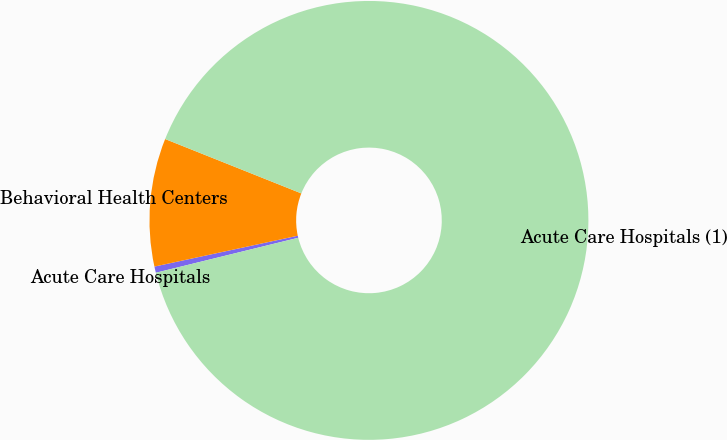Convert chart. <chart><loc_0><loc_0><loc_500><loc_500><pie_chart><fcel>Acute Care Hospitals<fcel>Behavioral Health Centers<fcel>Acute Care Hospitals (1)<nl><fcel>0.46%<fcel>9.42%<fcel>90.12%<nl></chart> 